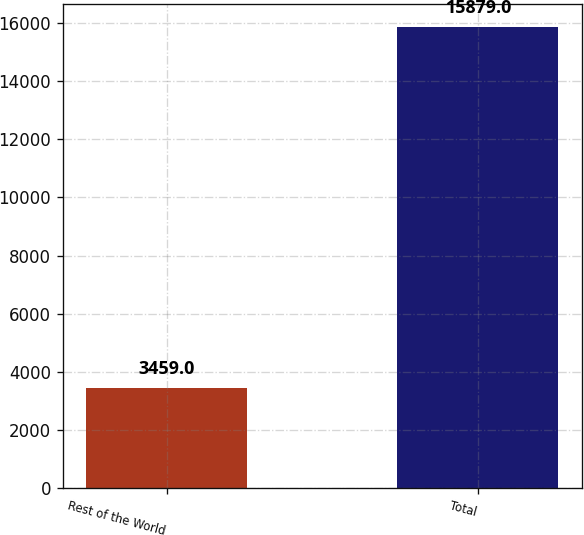Convert chart. <chart><loc_0><loc_0><loc_500><loc_500><bar_chart><fcel>Rest of the World<fcel>Total<nl><fcel>3459<fcel>15879<nl></chart> 